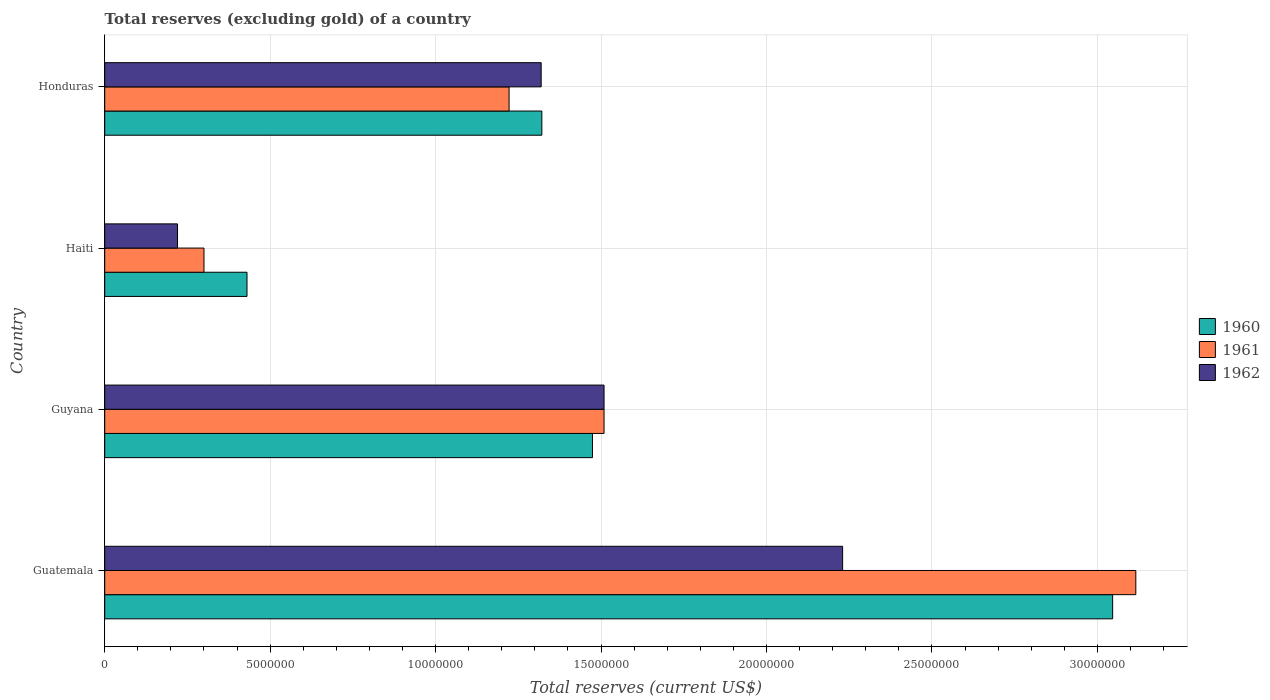How many different coloured bars are there?
Ensure brevity in your answer.  3. How many groups of bars are there?
Give a very brief answer. 4. Are the number of bars on each tick of the Y-axis equal?
Ensure brevity in your answer.  Yes. How many bars are there on the 4th tick from the top?
Provide a succinct answer. 3. What is the label of the 1st group of bars from the top?
Your answer should be compact. Honduras. In how many cases, is the number of bars for a given country not equal to the number of legend labels?
Offer a very short reply. 0. What is the total reserves (excluding gold) in 1962 in Haiti?
Offer a very short reply. 2.20e+06. Across all countries, what is the maximum total reserves (excluding gold) in 1962?
Offer a very short reply. 2.23e+07. Across all countries, what is the minimum total reserves (excluding gold) in 1962?
Provide a succinct answer. 2.20e+06. In which country was the total reserves (excluding gold) in 1962 maximum?
Keep it short and to the point. Guatemala. In which country was the total reserves (excluding gold) in 1961 minimum?
Your response must be concise. Haiti. What is the total total reserves (excluding gold) in 1962 in the graph?
Offer a very short reply. 5.28e+07. What is the difference between the total reserves (excluding gold) in 1962 in Guatemala and that in Guyana?
Offer a terse response. 7.21e+06. What is the difference between the total reserves (excluding gold) in 1961 in Guatemala and the total reserves (excluding gold) in 1962 in Honduras?
Keep it short and to the point. 1.80e+07. What is the average total reserves (excluding gold) in 1962 per country?
Give a very brief answer. 1.32e+07. What is the difference between the total reserves (excluding gold) in 1960 and total reserves (excluding gold) in 1961 in Guatemala?
Provide a succinct answer. -7.00e+05. What is the ratio of the total reserves (excluding gold) in 1961 in Guyana to that in Honduras?
Keep it short and to the point. 1.23. What is the difference between the highest and the second highest total reserves (excluding gold) in 1962?
Ensure brevity in your answer.  7.21e+06. What is the difference between the highest and the lowest total reserves (excluding gold) in 1960?
Offer a terse response. 2.62e+07. Is the sum of the total reserves (excluding gold) in 1960 in Guatemala and Haiti greater than the maximum total reserves (excluding gold) in 1962 across all countries?
Give a very brief answer. Yes. What does the 2nd bar from the bottom in Guyana represents?
Your answer should be compact. 1961. Is it the case that in every country, the sum of the total reserves (excluding gold) in 1962 and total reserves (excluding gold) in 1961 is greater than the total reserves (excluding gold) in 1960?
Your response must be concise. Yes. Are all the bars in the graph horizontal?
Offer a terse response. Yes. Are the values on the major ticks of X-axis written in scientific E-notation?
Offer a terse response. No. Does the graph contain grids?
Your response must be concise. Yes. Where does the legend appear in the graph?
Your response must be concise. Center right. How many legend labels are there?
Provide a short and direct response. 3. How are the legend labels stacked?
Provide a short and direct response. Vertical. What is the title of the graph?
Your answer should be very brief. Total reserves (excluding gold) of a country. Does "2012" appear as one of the legend labels in the graph?
Offer a very short reply. No. What is the label or title of the X-axis?
Your answer should be very brief. Total reserves (current US$). What is the Total reserves (current US$) in 1960 in Guatemala?
Keep it short and to the point. 3.05e+07. What is the Total reserves (current US$) of 1961 in Guatemala?
Your answer should be compact. 3.12e+07. What is the Total reserves (current US$) of 1962 in Guatemala?
Provide a short and direct response. 2.23e+07. What is the Total reserves (current US$) in 1960 in Guyana?
Make the answer very short. 1.47e+07. What is the Total reserves (current US$) in 1961 in Guyana?
Your answer should be compact. 1.51e+07. What is the Total reserves (current US$) of 1962 in Guyana?
Ensure brevity in your answer.  1.51e+07. What is the Total reserves (current US$) of 1960 in Haiti?
Your answer should be compact. 4.30e+06. What is the Total reserves (current US$) of 1962 in Haiti?
Make the answer very short. 2.20e+06. What is the Total reserves (current US$) of 1960 in Honduras?
Your answer should be very brief. 1.32e+07. What is the Total reserves (current US$) of 1961 in Honduras?
Make the answer very short. 1.22e+07. What is the Total reserves (current US$) in 1962 in Honduras?
Your answer should be very brief. 1.32e+07. Across all countries, what is the maximum Total reserves (current US$) of 1960?
Ensure brevity in your answer.  3.05e+07. Across all countries, what is the maximum Total reserves (current US$) of 1961?
Your answer should be very brief. 3.12e+07. Across all countries, what is the maximum Total reserves (current US$) of 1962?
Keep it short and to the point. 2.23e+07. Across all countries, what is the minimum Total reserves (current US$) of 1960?
Make the answer very short. 4.30e+06. Across all countries, what is the minimum Total reserves (current US$) of 1961?
Your response must be concise. 3.00e+06. Across all countries, what is the minimum Total reserves (current US$) in 1962?
Keep it short and to the point. 2.20e+06. What is the total Total reserves (current US$) of 1960 in the graph?
Provide a succinct answer. 6.27e+07. What is the total Total reserves (current US$) of 1961 in the graph?
Your answer should be very brief. 6.15e+07. What is the total Total reserves (current US$) in 1962 in the graph?
Keep it short and to the point. 5.28e+07. What is the difference between the Total reserves (current US$) of 1960 in Guatemala and that in Guyana?
Give a very brief answer. 1.57e+07. What is the difference between the Total reserves (current US$) in 1961 in Guatemala and that in Guyana?
Provide a succinct answer. 1.61e+07. What is the difference between the Total reserves (current US$) in 1962 in Guatemala and that in Guyana?
Your answer should be very brief. 7.21e+06. What is the difference between the Total reserves (current US$) in 1960 in Guatemala and that in Haiti?
Offer a very short reply. 2.62e+07. What is the difference between the Total reserves (current US$) of 1961 in Guatemala and that in Haiti?
Provide a short and direct response. 2.82e+07. What is the difference between the Total reserves (current US$) of 1962 in Guatemala and that in Haiti?
Keep it short and to the point. 2.01e+07. What is the difference between the Total reserves (current US$) of 1960 in Guatemala and that in Honduras?
Offer a terse response. 1.72e+07. What is the difference between the Total reserves (current US$) in 1961 in Guatemala and that in Honduras?
Ensure brevity in your answer.  1.89e+07. What is the difference between the Total reserves (current US$) of 1962 in Guatemala and that in Honduras?
Your response must be concise. 9.11e+06. What is the difference between the Total reserves (current US$) of 1960 in Guyana and that in Haiti?
Provide a succinct answer. 1.04e+07. What is the difference between the Total reserves (current US$) in 1961 in Guyana and that in Haiti?
Give a very brief answer. 1.21e+07. What is the difference between the Total reserves (current US$) in 1962 in Guyana and that in Haiti?
Offer a terse response. 1.29e+07. What is the difference between the Total reserves (current US$) in 1960 in Guyana and that in Honduras?
Offer a terse response. 1.53e+06. What is the difference between the Total reserves (current US$) of 1961 in Guyana and that in Honduras?
Your answer should be compact. 2.87e+06. What is the difference between the Total reserves (current US$) of 1962 in Guyana and that in Honduras?
Give a very brief answer. 1.90e+06. What is the difference between the Total reserves (current US$) of 1960 in Haiti and that in Honduras?
Provide a succinct answer. -8.91e+06. What is the difference between the Total reserves (current US$) in 1961 in Haiti and that in Honduras?
Offer a terse response. -9.22e+06. What is the difference between the Total reserves (current US$) in 1962 in Haiti and that in Honduras?
Give a very brief answer. -1.10e+07. What is the difference between the Total reserves (current US$) in 1960 in Guatemala and the Total reserves (current US$) in 1961 in Guyana?
Offer a very short reply. 1.54e+07. What is the difference between the Total reserves (current US$) of 1960 in Guatemala and the Total reserves (current US$) of 1962 in Guyana?
Your response must be concise. 1.54e+07. What is the difference between the Total reserves (current US$) of 1961 in Guatemala and the Total reserves (current US$) of 1962 in Guyana?
Your answer should be compact. 1.61e+07. What is the difference between the Total reserves (current US$) in 1960 in Guatemala and the Total reserves (current US$) in 1961 in Haiti?
Provide a succinct answer. 2.75e+07. What is the difference between the Total reserves (current US$) of 1960 in Guatemala and the Total reserves (current US$) of 1962 in Haiti?
Offer a very short reply. 2.83e+07. What is the difference between the Total reserves (current US$) in 1961 in Guatemala and the Total reserves (current US$) in 1962 in Haiti?
Keep it short and to the point. 2.90e+07. What is the difference between the Total reserves (current US$) in 1960 in Guatemala and the Total reserves (current US$) in 1961 in Honduras?
Offer a very short reply. 1.82e+07. What is the difference between the Total reserves (current US$) of 1960 in Guatemala and the Total reserves (current US$) of 1962 in Honduras?
Offer a terse response. 1.73e+07. What is the difference between the Total reserves (current US$) in 1961 in Guatemala and the Total reserves (current US$) in 1962 in Honduras?
Make the answer very short. 1.80e+07. What is the difference between the Total reserves (current US$) of 1960 in Guyana and the Total reserves (current US$) of 1961 in Haiti?
Your answer should be compact. 1.17e+07. What is the difference between the Total reserves (current US$) in 1960 in Guyana and the Total reserves (current US$) in 1962 in Haiti?
Provide a short and direct response. 1.25e+07. What is the difference between the Total reserves (current US$) of 1961 in Guyana and the Total reserves (current US$) of 1962 in Haiti?
Your answer should be compact. 1.29e+07. What is the difference between the Total reserves (current US$) of 1960 in Guyana and the Total reserves (current US$) of 1961 in Honduras?
Offer a very short reply. 2.52e+06. What is the difference between the Total reserves (current US$) in 1960 in Guyana and the Total reserves (current US$) in 1962 in Honduras?
Your answer should be compact. 1.55e+06. What is the difference between the Total reserves (current US$) in 1961 in Guyana and the Total reserves (current US$) in 1962 in Honduras?
Your response must be concise. 1.90e+06. What is the difference between the Total reserves (current US$) in 1960 in Haiti and the Total reserves (current US$) in 1961 in Honduras?
Your response must be concise. -7.92e+06. What is the difference between the Total reserves (current US$) of 1960 in Haiti and the Total reserves (current US$) of 1962 in Honduras?
Ensure brevity in your answer.  -8.89e+06. What is the difference between the Total reserves (current US$) of 1961 in Haiti and the Total reserves (current US$) of 1962 in Honduras?
Offer a terse response. -1.02e+07. What is the average Total reserves (current US$) in 1960 per country?
Provide a short and direct response. 1.57e+07. What is the average Total reserves (current US$) of 1961 per country?
Ensure brevity in your answer.  1.54e+07. What is the average Total reserves (current US$) of 1962 per country?
Make the answer very short. 1.32e+07. What is the difference between the Total reserves (current US$) in 1960 and Total reserves (current US$) in 1961 in Guatemala?
Your answer should be very brief. -7.00e+05. What is the difference between the Total reserves (current US$) in 1960 and Total reserves (current US$) in 1962 in Guatemala?
Offer a very short reply. 8.16e+06. What is the difference between the Total reserves (current US$) in 1961 and Total reserves (current US$) in 1962 in Guatemala?
Your answer should be very brief. 8.86e+06. What is the difference between the Total reserves (current US$) in 1960 and Total reserves (current US$) in 1961 in Guyana?
Make the answer very short. -3.50e+05. What is the difference between the Total reserves (current US$) of 1960 and Total reserves (current US$) of 1962 in Guyana?
Your response must be concise. -3.50e+05. What is the difference between the Total reserves (current US$) in 1961 and Total reserves (current US$) in 1962 in Guyana?
Make the answer very short. 0. What is the difference between the Total reserves (current US$) in 1960 and Total reserves (current US$) in 1961 in Haiti?
Offer a very short reply. 1.30e+06. What is the difference between the Total reserves (current US$) of 1960 and Total reserves (current US$) of 1962 in Haiti?
Make the answer very short. 2.10e+06. What is the difference between the Total reserves (current US$) of 1961 and Total reserves (current US$) of 1962 in Haiti?
Give a very brief answer. 8.00e+05. What is the difference between the Total reserves (current US$) of 1960 and Total reserves (current US$) of 1961 in Honduras?
Keep it short and to the point. 9.90e+05. What is the difference between the Total reserves (current US$) of 1961 and Total reserves (current US$) of 1962 in Honduras?
Keep it short and to the point. -9.70e+05. What is the ratio of the Total reserves (current US$) in 1960 in Guatemala to that in Guyana?
Provide a short and direct response. 2.07. What is the ratio of the Total reserves (current US$) of 1961 in Guatemala to that in Guyana?
Ensure brevity in your answer.  2.06. What is the ratio of the Total reserves (current US$) in 1962 in Guatemala to that in Guyana?
Give a very brief answer. 1.48. What is the ratio of the Total reserves (current US$) of 1960 in Guatemala to that in Haiti?
Your answer should be compact. 7.08. What is the ratio of the Total reserves (current US$) in 1961 in Guatemala to that in Haiti?
Offer a very short reply. 10.39. What is the ratio of the Total reserves (current US$) in 1962 in Guatemala to that in Haiti?
Your answer should be very brief. 10.14. What is the ratio of the Total reserves (current US$) of 1960 in Guatemala to that in Honduras?
Give a very brief answer. 2.31. What is the ratio of the Total reserves (current US$) of 1961 in Guatemala to that in Honduras?
Give a very brief answer. 2.55. What is the ratio of the Total reserves (current US$) in 1962 in Guatemala to that in Honduras?
Your answer should be compact. 1.69. What is the ratio of the Total reserves (current US$) of 1960 in Guyana to that in Haiti?
Your answer should be compact. 3.43. What is the ratio of the Total reserves (current US$) in 1961 in Guyana to that in Haiti?
Provide a succinct answer. 5.03. What is the ratio of the Total reserves (current US$) in 1962 in Guyana to that in Haiti?
Provide a short and direct response. 6.86. What is the ratio of the Total reserves (current US$) in 1960 in Guyana to that in Honduras?
Provide a short and direct response. 1.12. What is the ratio of the Total reserves (current US$) of 1961 in Guyana to that in Honduras?
Your answer should be compact. 1.23. What is the ratio of the Total reserves (current US$) of 1962 in Guyana to that in Honduras?
Offer a terse response. 1.14. What is the ratio of the Total reserves (current US$) of 1960 in Haiti to that in Honduras?
Give a very brief answer. 0.33. What is the ratio of the Total reserves (current US$) in 1961 in Haiti to that in Honduras?
Ensure brevity in your answer.  0.25. What is the ratio of the Total reserves (current US$) of 1962 in Haiti to that in Honduras?
Offer a terse response. 0.17. What is the difference between the highest and the second highest Total reserves (current US$) of 1960?
Offer a very short reply. 1.57e+07. What is the difference between the highest and the second highest Total reserves (current US$) in 1961?
Make the answer very short. 1.61e+07. What is the difference between the highest and the second highest Total reserves (current US$) in 1962?
Ensure brevity in your answer.  7.21e+06. What is the difference between the highest and the lowest Total reserves (current US$) of 1960?
Offer a terse response. 2.62e+07. What is the difference between the highest and the lowest Total reserves (current US$) of 1961?
Your response must be concise. 2.82e+07. What is the difference between the highest and the lowest Total reserves (current US$) in 1962?
Ensure brevity in your answer.  2.01e+07. 